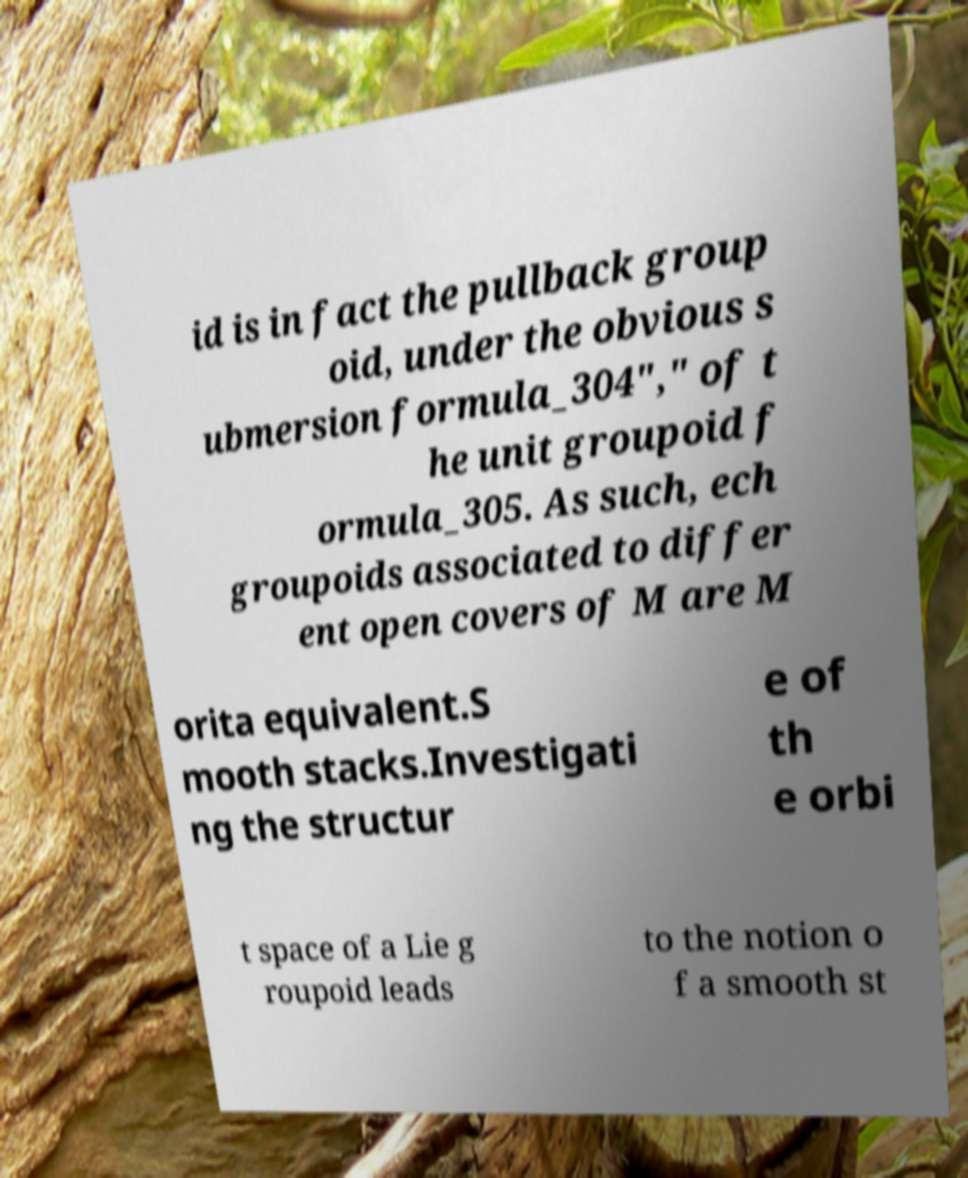Could you assist in decoding the text presented in this image and type it out clearly? id is in fact the pullback group oid, under the obvious s ubmersion formula_304"," of t he unit groupoid f ormula_305. As such, ech groupoids associated to differ ent open covers of M are M orita equivalent.S mooth stacks.Investigati ng the structur e of th e orbi t space of a Lie g roupoid leads to the notion o f a smooth st 